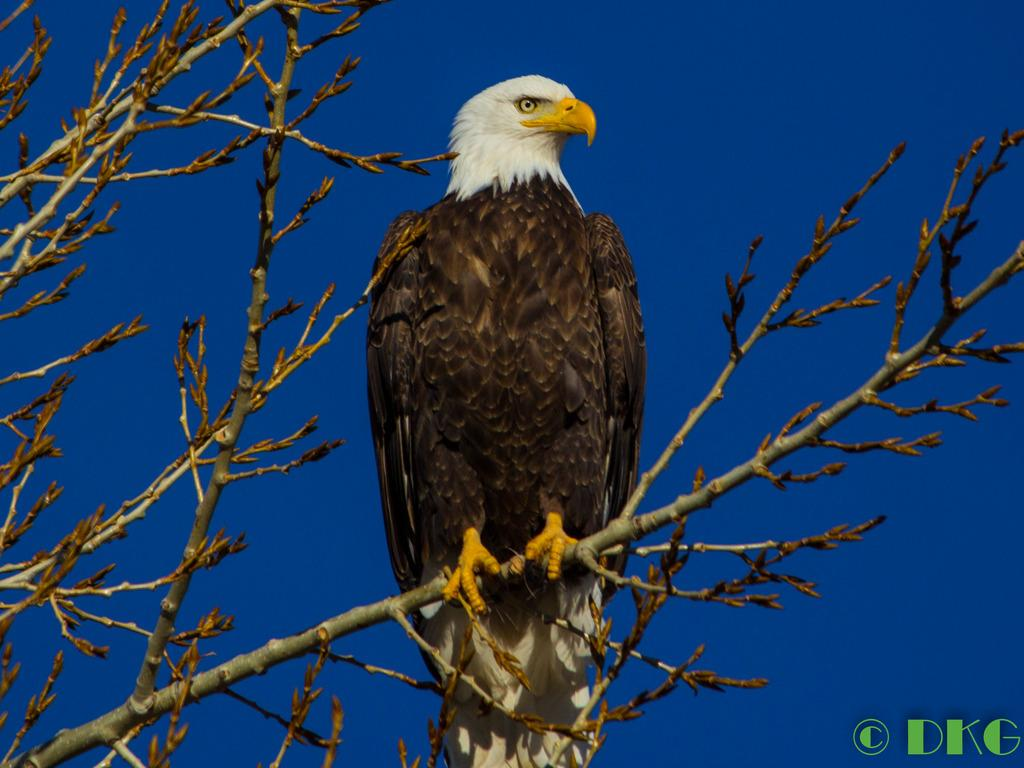What animal can be seen in the picture? There is an eagle in the picture. Where is the eagle sitting? The eagle is sitting on a dried tree stem. What can be seen in the background of the picture? The sky is visible in the picture. What is the color of the sky in the image? The sky is blue in color. What type of drink is the eagle teaching in the image? There is no drink or teaching activity present in the image; it features an eagle sitting on a dried tree stem with a blue sky in the background. 